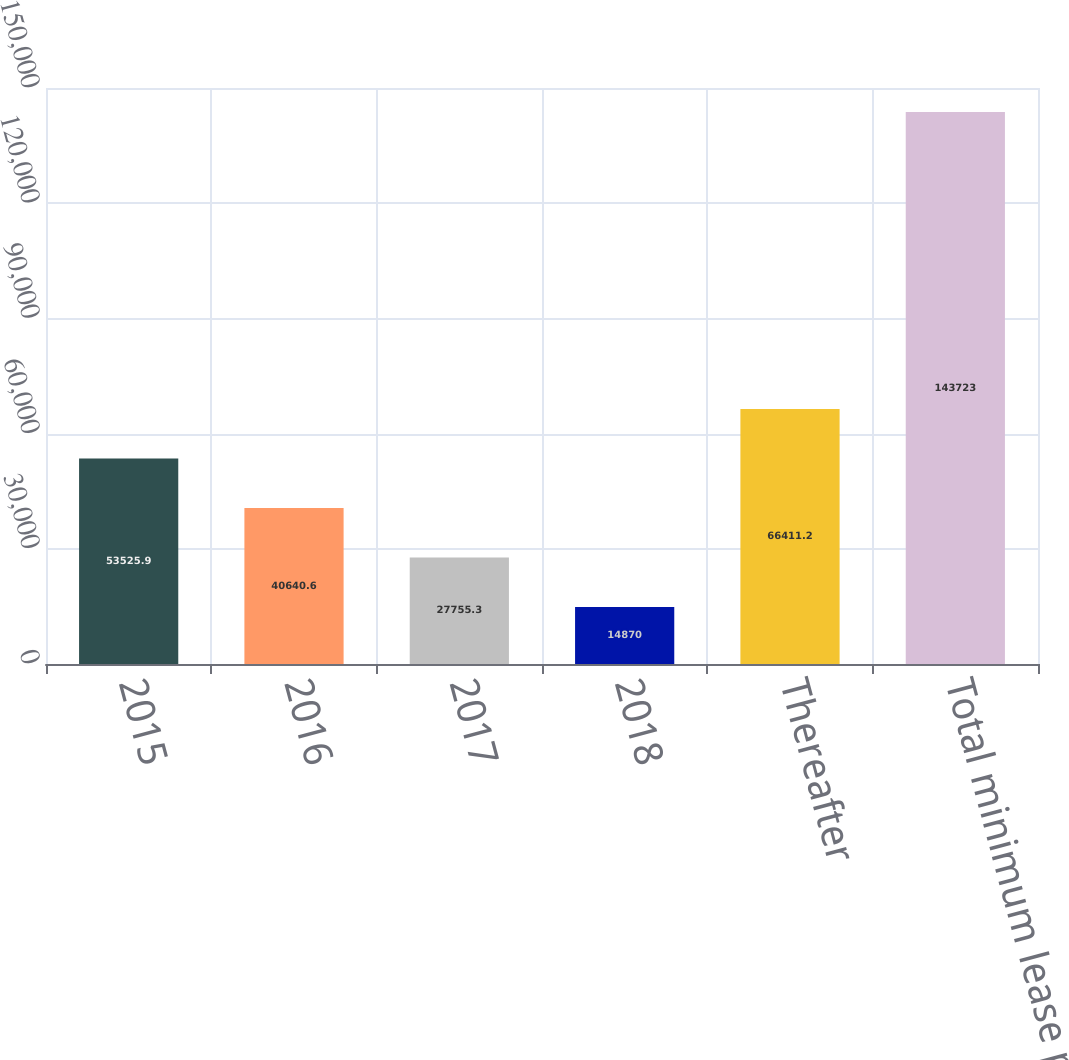Convert chart. <chart><loc_0><loc_0><loc_500><loc_500><bar_chart><fcel>2015<fcel>2016<fcel>2017<fcel>2018<fcel>Thereafter<fcel>Total minimum lease payments<nl><fcel>53525.9<fcel>40640.6<fcel>27755.3<fcel>14870<fcel>66411.2<fcel>143723<nl></chart> 